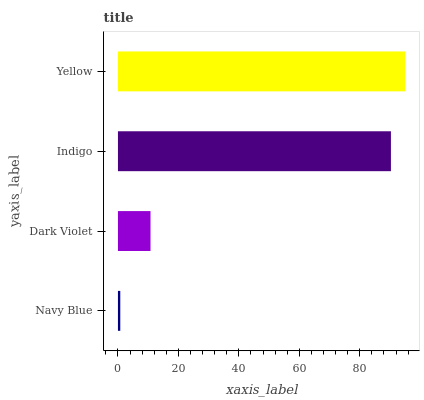Is Navy Blue the minimum?
Answer yes or no. Yes. Is Yellow the maximum?
Answer yes or no. Yes. Is Dark Violet the minimum?
Answer yes or no. No. Is Dark Violet the maximum?
Answer yes or no. No. Is Dark Violet greater than Navy Blue?
Answer yes or no. Yes. Is Navy Blue less than Dark Violet?
Answer yes or no. Yes. Is Navy Blue greater than Dark Violet?
Answer yes or no. No. Is Dark Violet less than Navy Blue?
Answer yes or no. No. Is Indigo the high median?
Answer yes or no. Yes. Is Dark Violet the low median?
Answer yes or no. Yes. Is Yellow the high median?
Answer yes or no. No. Is Indigo the low median?
Answer yes or no. No. 